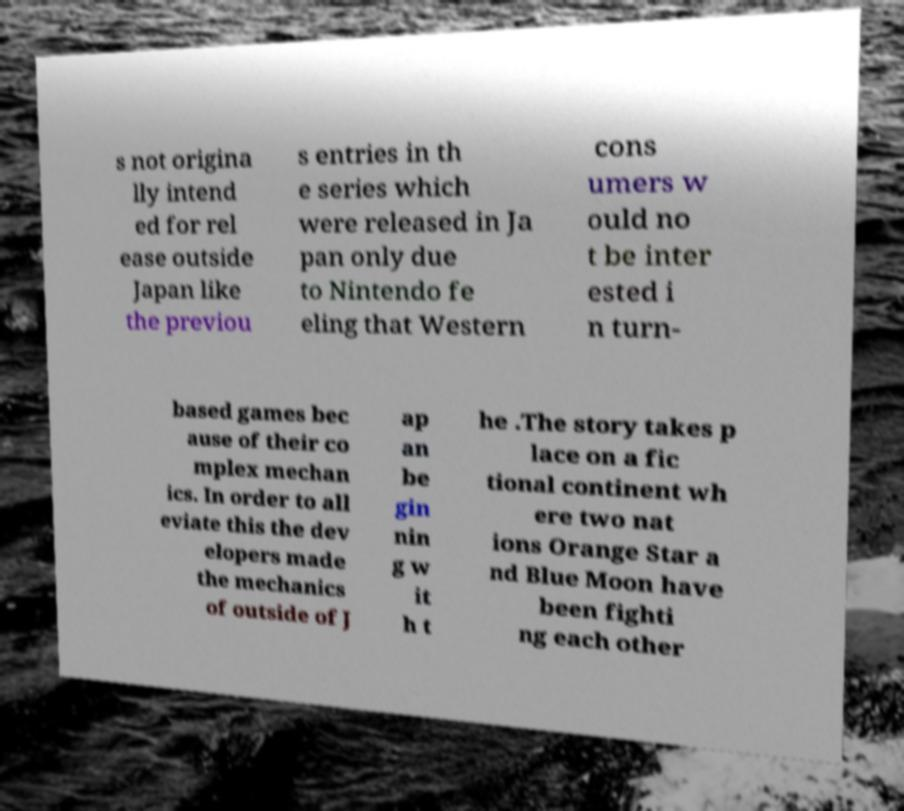There's text embedded in this image that I need extracted. Can you transcribe it verbatim? s not origina lly intend ed for rel ease outside Japan like the previou s entries in th e series which were released in Ja pan only due to Nintendo fe eling that Western cons umers w ould no t be inter ested i n turn- based games bec ause of their co mplex mechan ics. In order to all eviate this the dev elopers made the mechanics of outside of J ap an be gin nin g w it h t he .The story takes p lace on a fic tional continent wh ere two nat ions Orange Star a nd Blue Moon have been fighti ng each other 